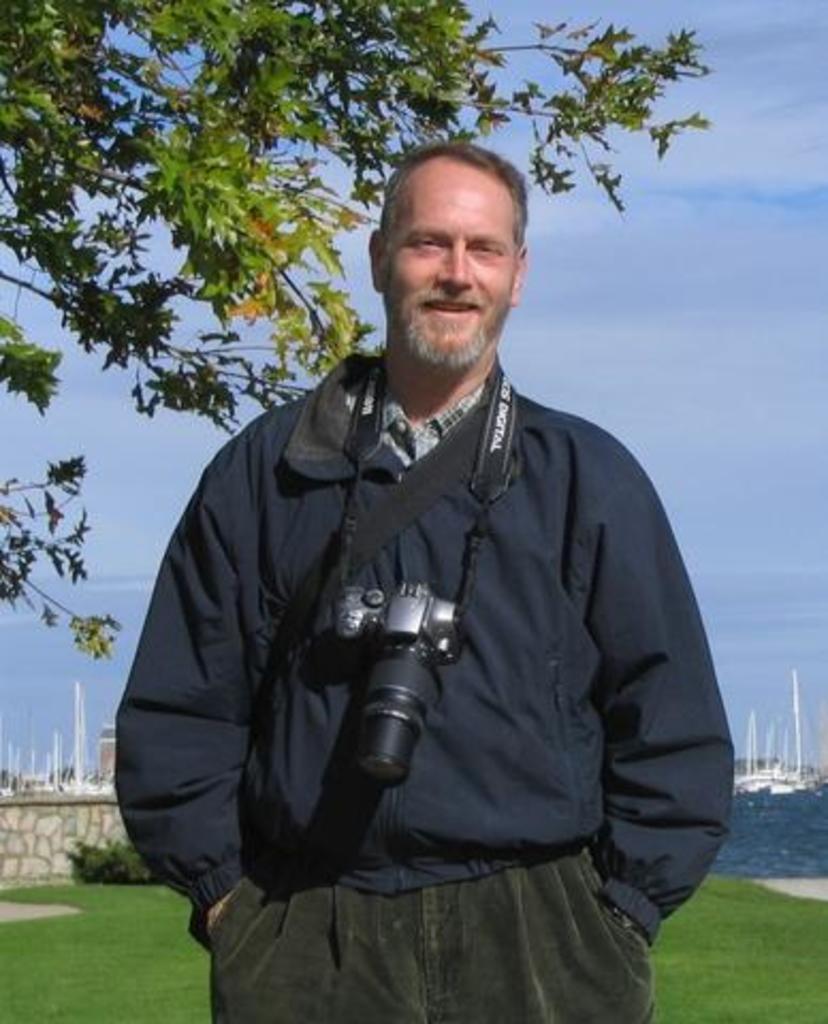Could you give a brief overview of what you see in this image? This is the man wearing jerkin and trouser. He is standing. He wore camera on his neck. This is a tree. These are the small bushes. I think these are the ships on the water. This looks like a wall. This is a grass. 